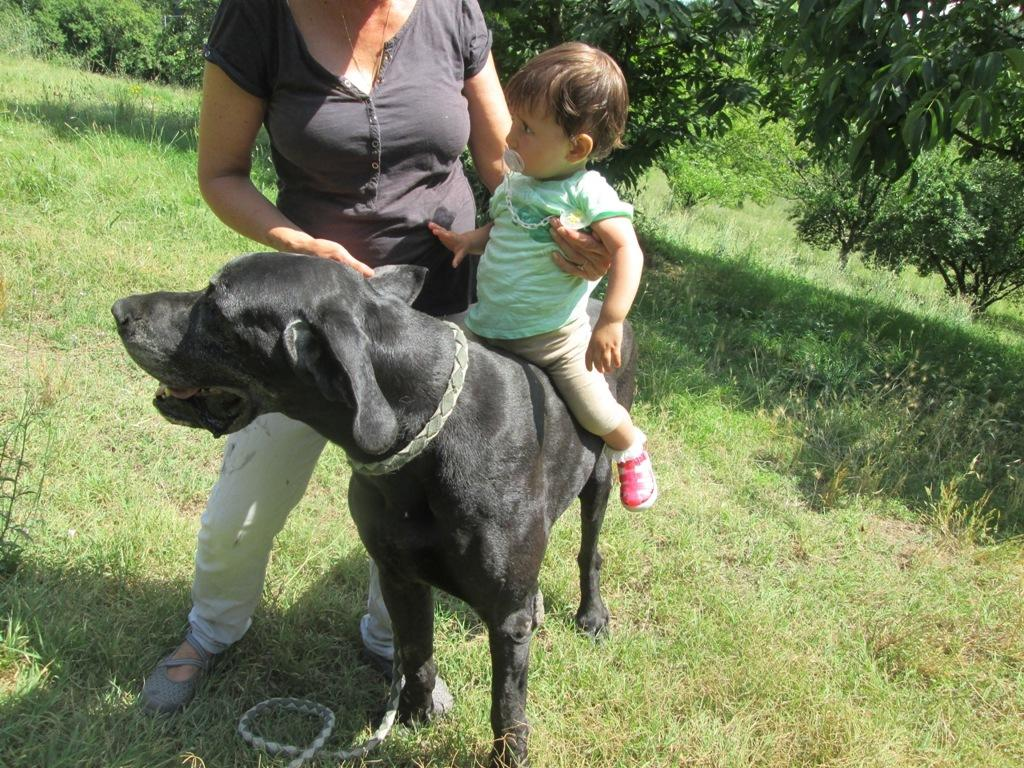What type of vegetation can be seen in the image? There are trees and grass in the image. How many people are present in the image? There are two persons in the image. What is the child doing in the image? The child is sitting on a black color dog. Can you see any kittens playing a guitar in the image? No, there are no kittens or guitars present in the image. What type of education is being provided in the image? There is no indication of any educational activity in the image. 